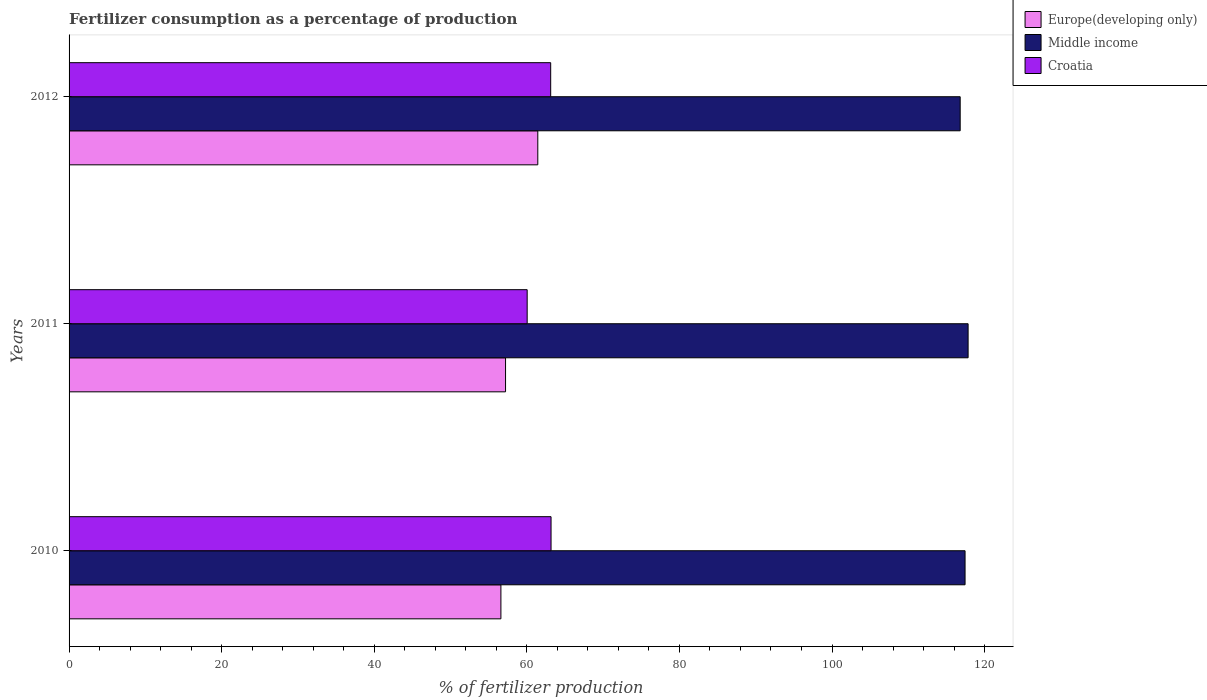How many groups of bars are there?
Offer a terse response. 3. Are the number of bars on each tick of the Y-axis equal?
Make the answer very short. Yes. What is the label of the 2nd group of bars from the top?
Provide a succinct answer. 2011. In how many cases, is the number of bars for a given year not equal to the number of legend labels?
Make the answer very short. 0. What is the percentage of fertilizers consumed in Croatia in 2011?
Give a very brief answer. 60.04. Across all years, what is the maximum percentage of fertilizers consumed in Europe(developing only)?
Offer a terse response. 61.44. Across all years, what is the minimum percentage of fertilizers consumed in Europe(developing only)?
Provide a short and direct response. 56.6. In which year was the percentage of fertilizers consumed in Middle income maximum?
Your response must be concise. 2011. In which year was the percentage of fertilizers consumed in Europe(developing only) minimum?
Keep it short and to the point. 2010. What is the total percentage of fertilizers consumed in Middle income in the graph?
Give a very brief answer. 352.07. What is the difference between the percentage of fertilizers consumed in Europe(developing only) in 2011 and that in 2012?
Offer a terse response. -4.23. What is the difference between the percentage of fertilizers consumed in Europe(developing only) in 2010 and the percentage of fertilizers consumed in Middle income in 2011?
Keep it short and to the point. -61.24. What is the average percentage of fertilizers consumed in Middle income per year?
Keep it short and to the point. 117.36. In the year 2011, what is the difference between the percentage of fertilizers consumed in Europe(developing only) and percentage of fertilizers consumed in Middle income?
Provide a succinct answer. -60.63. In how many years, is the percentage of fertilizers consumed in Croatia greater than 4 %?
Ensure brevity in your answer.  3. What is the ratio of the percentage of fertilizers consumed in Middle income in 2010 to that in 2011?
Offer a very short reply. 1. Is the difference between the percentage of fertilizers consumed in Europe(developing only) in 2010 and 2012 greater than the difference between the percentage of fertilizers consumed in Middle income in 2010 and 2012?
Provide a succinct answer. No. What is the difference between the highest and the second highest percentage of fertilizers consumed in Croatia?
Provide a short and direct response. 0.05. What is the difference between the highest and the lowest percentage of fertilizers consumed in Croatia?
Your answer should be compact. 3.13. In how many years, is the percentage of fertilizers consumed in Croatia greater than the average percentage of fertilizers consumed in Croatia taken over all years?
Keep it short and to the point. 2. What does the 1st bar from the bottom in 2010 represents?
Provide a short and direct response. Europe(developing only). Are the values on the major ticks of X-axis written in scientific E-notation?
Your answer should be compact. No. Does the graph contain grids?
Provide a succinct answer. No. Where does the legend appear in the graph?
Provide a succinct answer. Top right. How many legend labels are there?
Your response must be concise. 3. How are the legend labels stacked?
Provide a succinct answer. Vertical. What is the title of the graph?
Your answer should be compact. Fertilizer consumption as a percentage of production. What is the label or title of the X-axis?
Give a very brief answer. % of fertilizer production. What is the label or title of the Y-axis?
Your response must be concise. Years. What is the % of fertilizer production in Europe(developing only) in 2010?
Offer a terse response. 56.6. What is the % of fertilizer production of Middle income in 2010?
Your answer should be compact. 117.44. What is the % of fertilizer production of Croatia in 2010?
Ensure brevity in your answer.  63.17. What is the % of fertilizer production in Europe(developing only) in 2011?
Give a very brief answer. 57.21. What is the % of fertilizer production in Middle income in 2011?
Provide a succinct answer. 117.84. What is the % of fertilizer production in Croatia in 2011?
Keep it short and to the point. 60.04. What is the % of fertilizer production in Europe(developing only) in 2012?
Provide a succinct answer. 61.44. What is the % of fertilizer production of Middle income in 2012?
Offer a terse response. 116.8. What is the % of fertilizer production of Croatia in 2012?
Give a very brief answer. 63.12. Across all years, what is the maximum % of fertilizer production of Europe(developing only)?
Provide a short and direct response. 61.44. Across all years, what is the maximum % of fertilizer production in Middle income?
Offer a terse response. 117.84. Across all years, what is the maximum % of fertilizer production in Croatia?
Give a very brief answer. 63.17. Across all years, what is the minimum % of fertilizer production in Europe(developing only)?
Give a very brief answer. 56.6. Across all years, what is the minimum % of fertilizer production in Middle income?
Offer a terse response. 116.8. Across all years, what is the minimum % of fertilizer production in Croatia?
Your answer should be compact. 60.04. What is the total % of fertilizer production of Europe(developing only) in the graph?
Keep it short and to the point. 175.25. What is the total % of fertilizer production of Middle income in the graph?
Keep it short and to the point. 352.07. What is the total % of fertilizer production of Croatia in the graph?
Provide a short and direct response. 186.34. What is the difference between the % of fertilizer production in Europe(developing only) in 2010 and that in 2011?
Provide a short and direct response. -0.61. What is the difference between the % of fertilizer production of Middle income in 2010 and that in 2011?
Your response must be concise. -0.4. What is the difference between the % of fertilizer production of Croatia in 2010 and that in 2011?
Offer a terse response. 3.13. What is the difference between the % of fertilizer production of Europe(developing only) in 2010 and that in 2012?
Offer a terse response. -4.84. What is the difference between the % of fertilizer production in Middle income in 2010 and that in 2012?
Provide a short and direct response. 0.64. What is the difference between the % of fertilizer production in Croatia in 2010 and that in 2012?
Your answer should be very brief. 0.05. What is the difference between the % of fertilizer production in Europe(developing only) in 2011 and that in 2012?
Provide a succinct answer. -4.23. What is the difference between the % of fertilizer production of Croatia in 2011 and that in 2012?
Ensure brevity in your answer.  -3.08. What is the difference between the % of fertilizer production in Europe(developing only) in 2010 and the % of fertilizer production in Middle income in 2011?
Offer a very short reply. -61.24. What is the difference between the % of fertilizer production in Europe(developing only) in 2010 and the % of fertilizer production in Croatia in 2011?
Your answer should be compact. -3.44. What is the difference between the % of fertilizer production of Middle income in 2010 and the % of fertilizer production of Croatia in 2011?
Give a very brief answer. 57.39. What is the difference between the % of fertilizer production of Europe(developing only) in 2010 and the % of fertilizer production of Middle income in 2012?
Provide a succinct answer. -60.2. What is the difference between the % of fertilizer production in Europe(developing only) in 2010 and the % of fertilizer production in Croatia in 2012?
Give a very brief answer. -6.52. What is the difference between the % of fertilizer production of Middle income in 2010 and the % of fertilizer production of Croatia in 2012?
Your answer should be very brief. 54.31. What is the difference between the % of fertilizer production in Europe(developing only) in 2011 and the % of fertilizer production in Middle income in 2012?
Your answer should be very brief. -59.59. What is the difference between the % of fertilizer production of Europe(developing only) in 2011 and the % of fertilizer production of Croatia in 2012?
Offer a very short reply. -5.92. What is the difference between the % of fertilizer production in Middle income in 2011 and the % of fertilizer production in Croatia in 2012?
Your response must be concise. 54.71. What is the average % of fertilizer production in Europe(developing only) per year?
Make the answer very short. 58.42. What is the average % of fertilizer production in Middle income per year?
Offer a terse response. 117.36. What is the average % of fertilizer production in Croatia per year?
Provide a short and direct response. 62.11. In the year 2010, what is the difference between the % of fertilizer production of Europe(developing only) and % of fertilizer production of Middle income?
Give a very brief answer. -60.84. In the year 2010, what is the difference between the % of fertilizer production in Europe(developing only) and % of fertilizer production in Croatia?
Offer a very short reply. -6.57. In the year 2010, what is the difference between the % of fertilizer production of Middle income and % of fertilizer production of Croatia?
Offer a very short reply. 54.27. In the year 2011, what is the difference between the % of fertilizer production of Europe(developing only) and % of fertilizer production of Middle income?
Provide a succinct answer. -60.63. In the year 2011, what is the difference between the % of fertilizer production of Europe(developing only) and % of fertilizer production of Croatia?
Your answer should be compact. -2.83. In the year 2011, what is the difference between the % of fertilizer production in Middle income and % of fertilizer production in Croatia?
Ensure brevity in your answer.  57.79. In the year 2012, what is the difference between the % of fertilizer production of Europe(developing only) and % of fertilizer production of Middle income?
Keep it short and to the point. -55.36. In the year 2012, what is the difference between the % of fertilizer production in Europe(developing only) and % of fertilizer production in Croatia?
Keep it short and to the point. -1.69. In the year 2012, what is the difference between the % of fertilizer production in Middle income and % of fertilizer production in Croatia?
Make the answer very short. 53.67. What is the ratio of the % of fertilizer production in Europe(developing only) in 2010 to that in 2011?
Give a very brief answer. 0.99. What is the ratio of the % of fertilizer production in Croatia in 2010 to that in 2011?
Ensure brevity in your answer.  1.05. What is the ratio of the % of fertilizer production of Europe(developing only) in 2010 to that in 2012?
Make the answer very short. 0.92. What is the ratio of the % of fertilizer production of Middle income in 2010 to that in 2012?
Your response must be concise. 1.01. What is the ratio of the % of fertilizer production in Europe(developing only) in 2011 to that in 2012?
Ensure brevity in your answer.  0.93. What is the ratio of the % of fertilizer production in Middle income in 2011 to that in 2012?
Provide a succinct answer. 1.01. What is the ratio of the % of fertilizer production of Croatia in 2011 to that in 2012?
Your response must be concise. 0.95. What is the difference between the highest and the second highest % of fertilizer production in Europe(developing only)?
Keep it short and to the point. 4.23. What is the difference between the highest and the second highest % of fertilizer production of Middle income?
Give a very brief answer. 0.4. What is the difference between the highest and the second highest % of fertilizer production of Croatia?
Your answer should be compact. 0.05. What is the difference between the highest and the lowest % of fertilizer production in Europe(developing only)?
Provide a succinct answer. 4.84. What is the difference between the highest and the lowest % of fertilizer production in Middle income?
Keep it short and to the point. 1.04. What is the difference between the highest and the lowest % of fertilizer production of Croatia?
Make the answer very short. 3.13. 